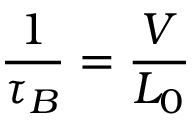Convert formula to latex. <formula><loc_0><loc_0><loc_500><loc_500>{ \frac { 1 } { \tau _ { B } } } = { \frac { V } { L _ { 0 } } }</formula> 